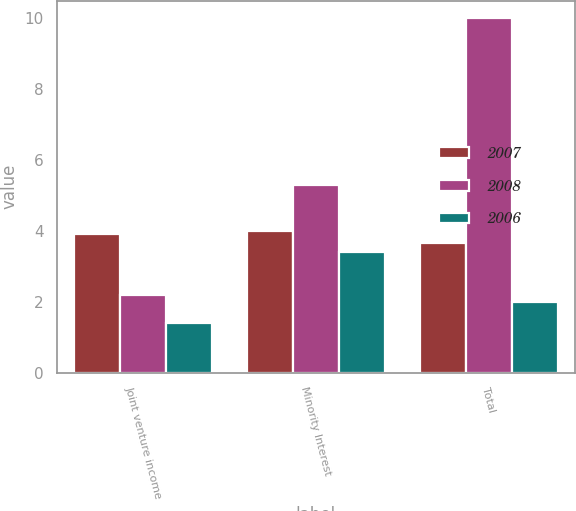Convert chart. <chart><loc_0><loc_0><loc_500><loc_500><stacked_bar_chart><ecel><fcel>Joint venture income<fcel>Minority Interest<fcel>Total<nl><fcel>2007<fcel>3.9<fcel>4<fcel>3.65<nl><fcel>2008<fcel>2.2<fcel>5.3<fcel>10<nl><fcel>2006<fcel>1.4<fcel>3.4<fcel>2<nl></chart> 